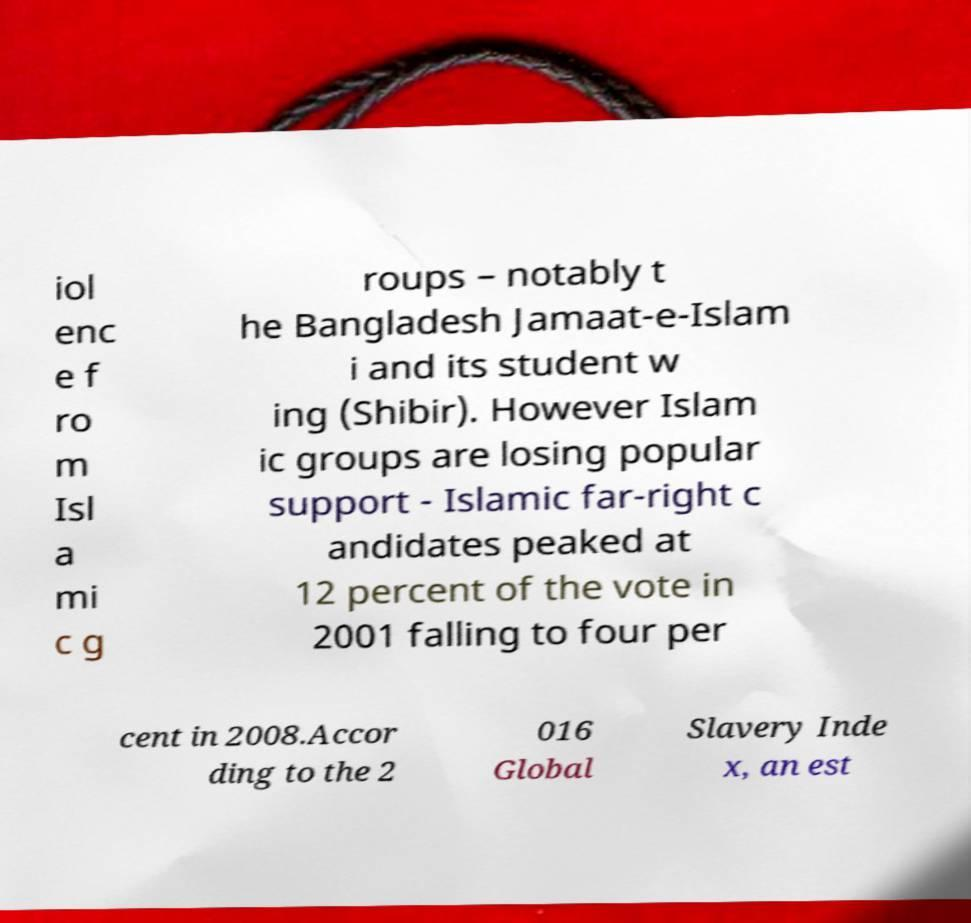For documentation purposes, I need the text within this image transcribed. Could you provide that? iol enc e f ro m Isl a mi c g roups – notably t he Bangladesh Jamaat-e-Islam i and its student w ing (Shibir). However Islam ic groups are losing popular support - Islamic far-right c andidates peaked at 12 percent of the vote in 2001 falling to four per cent in 2008.Accor ding to the 2 016 Global Slavery Inde x, an est 